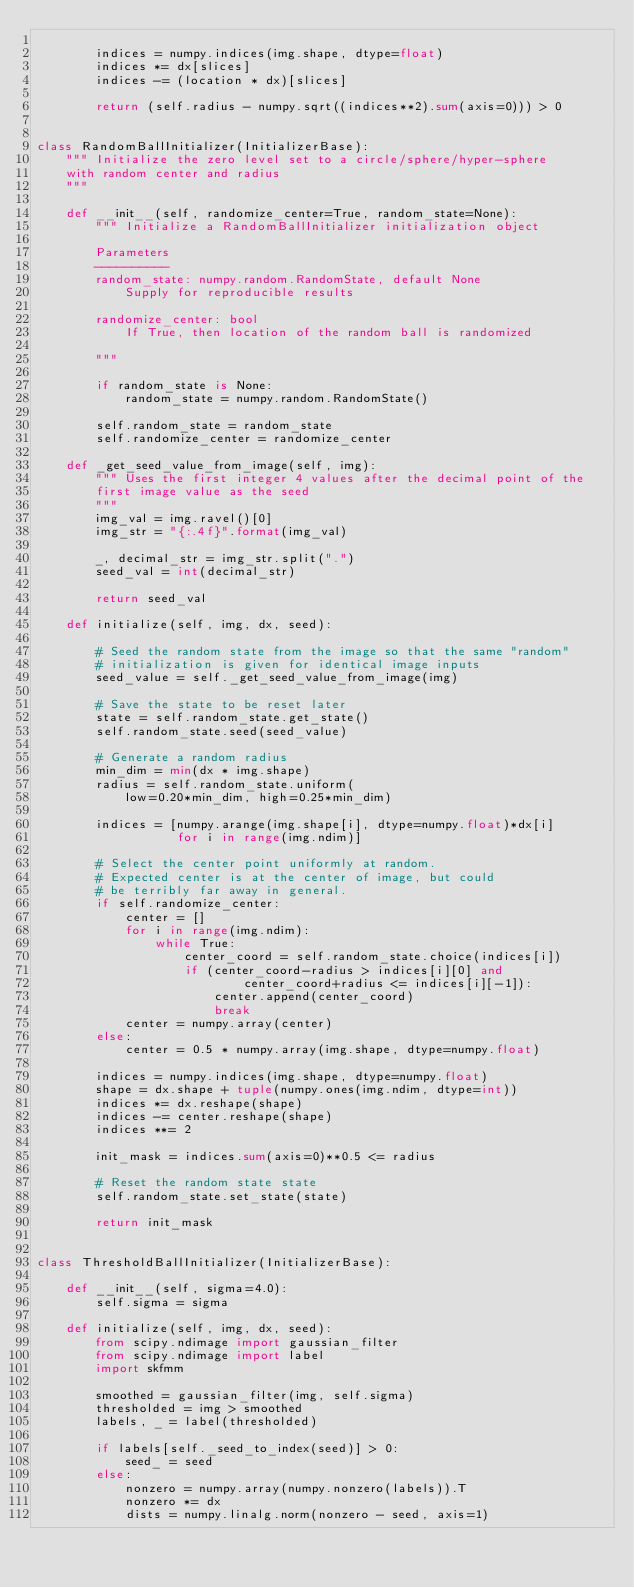Convert code to text. <code><loc_0><loc_0><loc_500><loc_500><_Python_>
        indices = numpy.indices(img.shape, dtype=float)
        indices *= dx[slices]
        indices -= (location * dx)[slices]

        return (self.radius - numpy.sqrt((indices**2).sum(axis=0))) > 0


class RandomBallInitializer(InitializerBase):
    """ Initialize the zero level set to a circle/sphere/hyper-sphere
    with random center and radius
    """

    def __init__(self, randomize_center=True, random_state=None):
        """ Initialize a RandomBallInitializer initialization object

        Parameters
        ----------
        random_state: numpy.random.RandomState, default None
            Supply for reproducible results

        randomize_center: bool
            If True, then location of the random ball is randomized

        """

        if random_state is None:
            random_state = numpy.random.RandomState()

        self.random_state = random_state
        self.randomize_center = randomize_center

    def _get_seed_value_from_image(self, img):
        """ Uses the first integer 4 values after the decimal point of the
        first image value as the seed
        """
        img_val = img.ravel()[0]
        img_str = "{:.4f}".format(img_val)

        _, decimal_str = img_str.split(".")
        seed_val = int(decimal_str)

        return seed_val

    def initialize(self, img, dx, seed):

        # Seed the random state from the image so that the same "random"
        # initialization is given for identical image inputs
        seed_value = self._get_seed_value_from_image(img)

        # Save the state to be reset later
        state = self.random_state.get_state()
        self.random_state.seed(seed_value)

        # Generate a random radius
        min_dim = min(dx * img.shape)
        radius = self.random_state.uniform(
            low=0.20*min_dim, high=0.25*min_dim)

        indices = [numpy.arange(img.shape[i], dtype=numpy.float)*dx[i]
                   for i in range(img.ndim)]

        # Select the center point uniformly at random.
        # Expected center is at the center of image, but could
        # be terribly far away in general.
        if self.randomize_center:
            center = []
            for i in range(img.ndim):
                while True:
                    center_coord = self.random_state.choice(indices[i])
                    if (center_coord-radius > indices[i][0] and
                            center_coord+radius <= indices[i][-1]):
                        center.append(center_coord)
                        break
            center = numpy.array(center)
        else:
            center = 0.5 * numpy.array(img.shape, dtype=numpy.float)

        indices = numpy.indices(img.shape, dtype=numpy.float)
        shape = dx.shape + tuple(numpy.ones(img.ndim, dtype=int))
        indices *= dx.reshape(shape)
        indices -= center.reshape(shape)
        indices **= 2

        init_mask = indices.sum(axis=0)**0.5 <= radius

        # Reset the random state state
        self.random_state.set_state(state)

        return init_mask


class ThresholdBallInitializer(InitializerBase):

    def __init__(self, sigma=4.0):
        self.sigma = sigma

    def initialize(self, img, dx, seed):
        from scipy.ndimage import gaussian_filter
        from scipy.ndimage import label
        import skfmm

        smoothed = gaussian_filter(img, self.sigma)
        thresholded = img > smoothed
        labels, _ = label(thresholded)

        if labels[self._seed_to_index(seed)] > 0:
            seed_ = seed
        else:
            nonzero = numpy.array(numpy.nonzero(labels)).T
            nonzero *= dx
            dists = numpy.linalg.norm(nonzero - seed, axis=1)</code> 